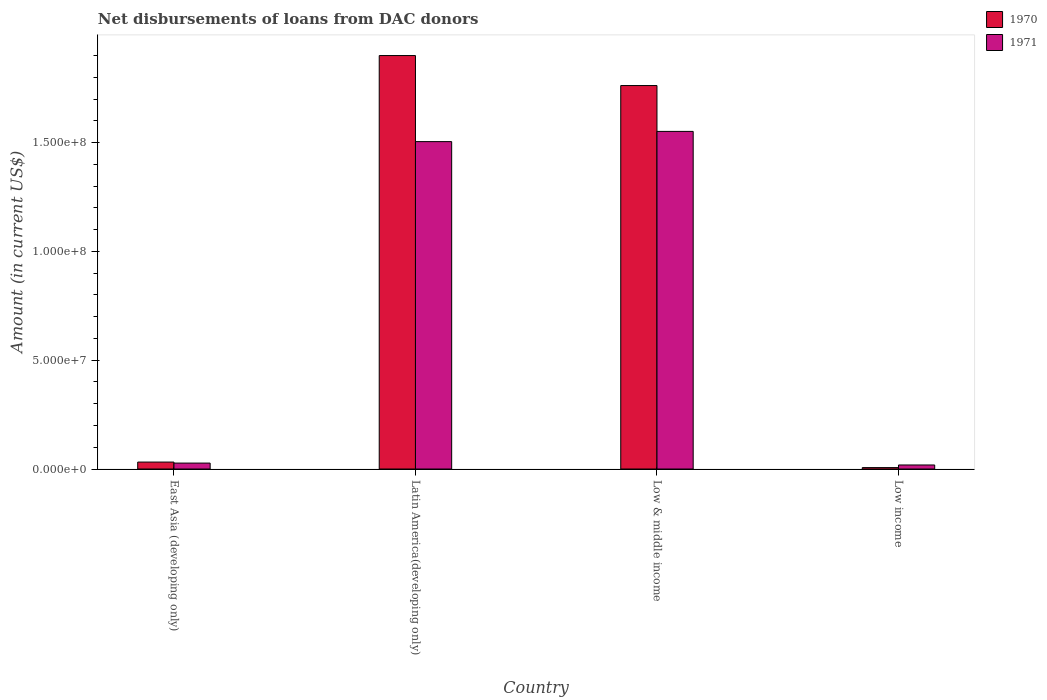How many bars are there on the 4th tick from the left?
Make the answer very short. 2. How many bars are there on the 1st tick from the right?
Ensure brevity in your answer.  2. What is the label of the 1st group of bars from the left?
Provide a succinct answer. East Asia (developing only). In how many cases, is the number of bars for a given country not equal to the number of legend labels?
Provide a succinct answer. 0. What is the amount of loans disbursed in 1970 in Low income?
Offer a very short reply. 6.47e+05. Across all countries, what is the maximum amount of loans disbursed in 1971?
Your response must be concise. 1.55e+08. Across all countries, what is the minimum amount of loans disbursed in 1971?
Keep it short and to the point. 1.86e+06. What is the total amount of loans disbursed in 1971 in the graph?
Make the answer very short. 3.10e+08. What is the difference between the amount of loans disbursed in 1971 in East Asia (developing only) and that in Latin America(developing only)?
Provide a succinct answer. -1.48e+08. What is the difference between the amount of loans disbursed in 1971 in Latin America(developing only) and the amount of loans disbursed in 1970 in East Asia (developing only)?
Provide a succinct answer. 1.47e+08. What is the average amount of loans disbursed in 1970 per country?
Make the answer very short. 9.25e+07. What is the difference between the amount of loans disbursed of/in 1971 and amount of loans disbursed of/in 1970 in Low & middle income?
Keep it short and to the point. -2.11e+07. In how many countries, is the amount of loans disbursed in 1971 greater than 40000000 US$?
Offer a terse response. 2. What is the ratio of the amount of loans disbursed in 1971 in East Asia (developing only) to that in Low income?
Your response must be concise. 1.47. Is the amount of loans disbursed in 1971 in Latin America(developing only) less than that in Low & middle income?
Provide a short and direct response. Yes. What is the difference between the highest and the second highest amount of loans disbursed in 1971?
Provide a short and direct response. 4.69e+06. What is the difference between the highest and the lowest amount of loans disbursed in 1971?
Ensure brevity in your answer.  1.53e+08. Is the sum of the amount of loans disbursed in 1970 in East Asia (developing only) and Latin America(developing only) greater than the maximum amount of loans disbursed in 1971 across all countries?
Your answer should be very brief. Yes. What does the 1st bar from the left in Latin America(developing only) represents?
Your answer should be very brief. 1970. How many bars are there?
Your answer should be very brief. 8. Are all the bars in the graph horizontal?
Provide a succinct answer. No. How many countries are there in the graph?
Ensure brevity in your answer.  4. Does the graph contain any zero values?
Offer a terse response. No. How many legend labels are there?
Provide a succinct answer. 2. What is the title of the graph?
Your answer should be very brief. Net disbursements of loans from DAC donors. Does "1968" appear as one of the legend labels in the graph?
Your response must be concise. No. What is the label or title of the X-axis?
Your answer should be very brief. Country. What is the Amount (in current US$) of 1970 in East Asia (developing only)?
Provide a short and direct response. 3.19e+06. What is the Amount (in current US$) in 1971 in East Asia (developing only)?
Your answer should be compact. 2.73e+06. What is the Amount (in current US$) in 1970 in Latin America(developing only)?
Your answer should be very brief. 1.90e+08. What is the Amount (in current US$) of 1971 in Latin America(developing only)?
Provide a short and direct response. 1.50e+08. What is the Amount (in current US$) in 1970 in Low & middle income?
Provide a succinct answer. 1.76e+08. What is the Amount (in current US$) in 1971 in Low & middle income?
Offer a very short reply. 1.55e+08. What is the Amount (in current US$) in 1970 in Low income?
Offer a very short reply. 6.47e+05. What is the Amount (in current US$) in 1971 in Low income?
Your response must be concise. 1.86e+06. Across all countries, what is the maximum Amount (in current US$) of 1970?
Your answer should be compact. 1.90e+08. Across all countries, what is the maximum Amount (in current US$) of 1971?
Make the answer very short. 1.55e+08. Across all countries, what is the minimum Amount (in current US$) of 1970?
Give a very brief answer. 6.47e+05. Across all countries, what is the minimum Amount (in current US$) of 1971?
Ensure brevity in your answer.  1.86e+06. What is the total Amount (in current US$) of 1970 in the graph?
Your answer should be very brief. 3.70e+08. What is the total Amount (in current US$) in 1971 in the graph?
Offer a terse response. 3.10e+08. What is the difference between the Amount (in current US$) in 1970 in East Asia (developing only) and that in Latin America(developing only)?
Your answer should be very brief. -1.87e+08. What is the difference between the Amount (in current US$) of 1971 in East Asia (developing only) and that in Latin America(developing only)?
Make the answer very short. -1.48e+08. What is the difference between the Amount (in current US$) of 1970 in East Asia (developing only) and that in Low & middle income?
Your response must be concise. -1.73e+08. What is the difference between the Amount (in current US$) of 1971 in East Asia (developing only) and that in Low & middle income?
Your answer should be compact. -1.52e+08. What is the difference between the Amount (in current US$) of 1970 in East Asia (developing only) and that in Low income?
Your answer should be very brief. 2.54e+06. What is the difference between the Amount (in current US$) of 1971 in East Asia (developing only) and that in Low income?
Provide a succinct answer. 8.69e+05. What is the difference between the Amount (in current US$) in 1970 in Latin America(developing only) and that in Low & middle income?
Your answer should be compact. 1.38e+07. What is the difference between the Amount (in current US$) in 1971 in Latin America(developing only) and that in Low & middle income?
Make the answer very short. -4.69e+06. What is the difference between the Amount (in current US$) of 1970 in Latin America(developing only) and that in Low income?
Offer a very short reply. 1.89e+08. What is the difference between the Amount (in current US$) of 1971 in Latin America(developing only) and that in Low income?
Provide a succinct answer. 1.49e+08. What is the difference between the Amount (in current US$) of 1970 in Low & middle income and that in Low income?
Your answer should be compact. 1.76e+08. What is the difference between the Amount (in current US$) in 1971 in Low & middle income and that in Low income?
Offer a very short reply. 1.53e+08. What is the difference between the Amount (in current US$) in 1970 in East Asia (developing only) and the Amount (in current US$) in 1971 in Latin America(developing only)?
Ensure brevity in your answer.  -1.47e+08. What is the difference between the Amount (in current US$) in 1970 in East Asia (developing only) and the Amount (in current US$) in 1971 in Low & middle income?
Your answer should be very brief. -1.52e+08. What is the difference between the Amount (in current US$) of 1970 in East Asia (developing only) and the Amount (in current US$) of 1971 in Low income?
Ensure brevity in your answer.  1.33e+06. What is the difference between the Amount (in current US$) in 1970 in Latin America(developing only) and the Amount (in current US$) in 1971 in Low & middle income?
Your answer should be very brief. 3.49e+07. What is the difference between the Amount (in current US$) in 1970 in Latin America(developing only) and the Amount (in current US$) in 1971 in Low income?
Make the answer very short. 1.88e+08. What is the difference between the Amount (in current US$) in 1970 in Low & middle income and the Amount (in current US$) in 1971 in Low income?
Provide a short and direct response. 1.74e+08. What is the average Amount (in current US$) in 1970 per country?
Your answer should be very brief. 9.25e+07. What is the average Amount (in current US$) in 1971 per country?
Your answer should be compact. 7.75e+07. What is the difference between the Amount (in current US$) in 1970 and Amount (in current US$) in 1971 in East Asia (developing only)?
Offer a very short reply. 4.61e+05. What is the difference between the Amount (in current US$) in 1970 and Amount (in current US$) in 1971 in Latin America(developing only)?
Your answer should be compact. 3.96e+07. What is the difference between the Amount (in current US$) in 1970 and Amount (in current US$) in 1971 in Low & middle income?
Offer a very short reply. 2.11e+07. What is the difference between the Amount (in current US$) of 1970 and Amount (in current US$) of 1971 in Low income?
Offer a terse response. -1.21e+06. What is the ratio of the Amount (in current US$) in 1970 in East Asia (developing only) to that in Latin America(developing only)?
Ensure brevity in your answer.  0.02. What is the ratio of the Amount (in current US$) of 1971 in East Asia (developing only) to that in Latin America(developing only)?
Your answer should be compact. 0.02. What is the ratio of the Amount (in current US$) of 1970 in East Asia (developing only) to that in Low & middle income?
Ensure brevity in your answer.  0.02. What is the ratio of the Amount (in current US$) of 1971 in East Asia (developing only) to that in Low & middle income?
Provide a succinct answer. 0.02. What is the ratio of the Amount (in current US$) in 1970 in East Asia (developing only) to that in Low income?
Provide a succinct answer. 4.93. What is the ratio of the Amount (in current US$) in 1971 in East Asia (developing only) to that in Low income?
Give a very brief answer. 1.47. What is the ratio of the Amount (in current US$) of 1970 in Latin America(developing only) to that in Low & middle income?
Keep it short and to the point. 1.08. What is the ratio of the Amount (in current US$) of 1971 in Latin America(developing only) to that in Low & middle income?
Offer a very short reply. 0.97. What is the ratio of the Amount (in current US$) of 1970 in Latin America(developing only) to that in Low income?
Ensure brevity in your answer.  293.65. What is the ratio of the Amount (in current US$) in 1971 in Latin America(developing only) to that in Low income?
Offer a very short reply. 80.93. What is the ratio of the Amount (in current US$) of 1970 in Low & middle income to that in Low income?
Offer a very short reply. 272.33. What is the ratio of the Amount (in current US$) of 1971 in Low & middle income to that in Low income?
Your response must be concise. 83.45. What is the difference between the highest and the second highest Amount (in current US$) of 1970?
Your answer should be compact. 1.38e+07. What is the difference between the highest and the second highest Amount (in current US$) in 1971?
Ensure brevity in your answer.  4.69e+06. What is the difference between the highest and the lowest Amount (in current US$) of 1970?
Your answer should be compact. 1.89e+08. What is the difference between the highest and the lowest Amount (in current US$) in 1971?
Make the answer very short. 1.53e+08. 